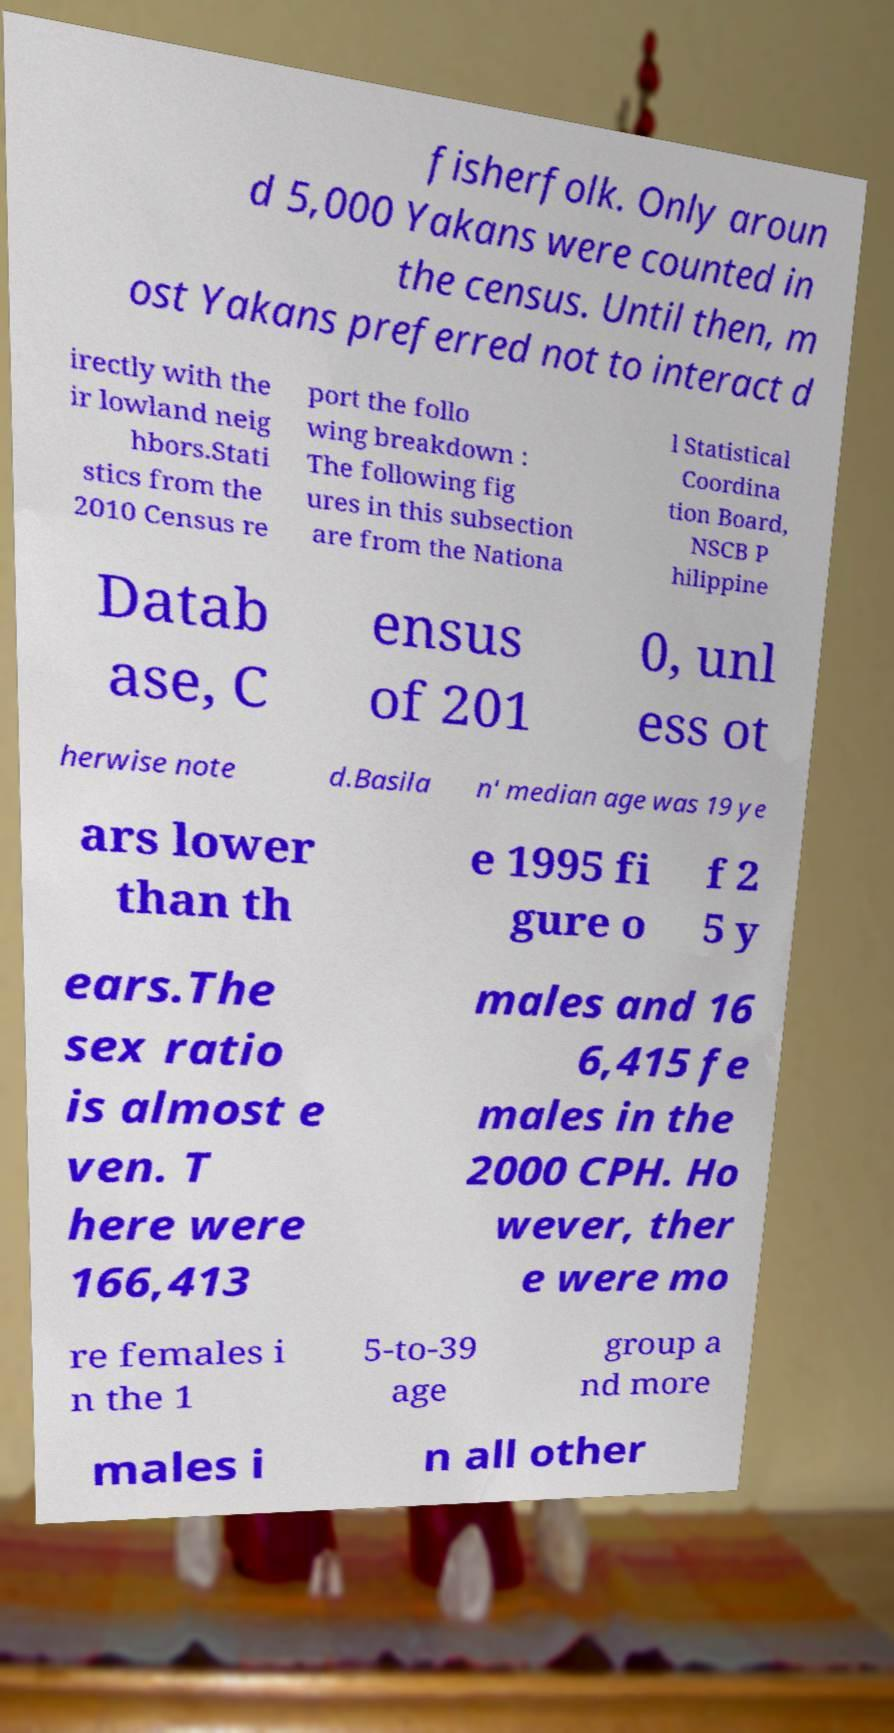Can you accurately transcribe the text from the provided image for me? fisherfolk. Only aroun d 5,000 Yakans were counted in the census. Until then, m ost Yakans preferred not to interact d irectly with the ir lowland neig hbors.Stati stics from the 2010 Census re port the follo wing breakdown : The following fig ures in this subsection are from the Nationa l Statistical Coordina tion Board, NSCB P hilippine Datab ase, C ensus of 201 0, unl ess ot herwise note d.Basila n' median age was 19 ye ars lower than th e 1995 fi gure o f 2 5 y ears.The sex ratio is almost e ven. T here were 166,413 males and 16 6,415 fe males in the 2000 CPH. Ho wever, ther e were mo re females i n the 1 5-to-39 age group a nd more males i n all other 